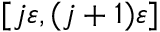Convert formula to latex. <formula><loc_0><loc_0><loc_500><loc_500>[ j \varepsilon , ( j + 1 ) \varepsilon ]</formula> 